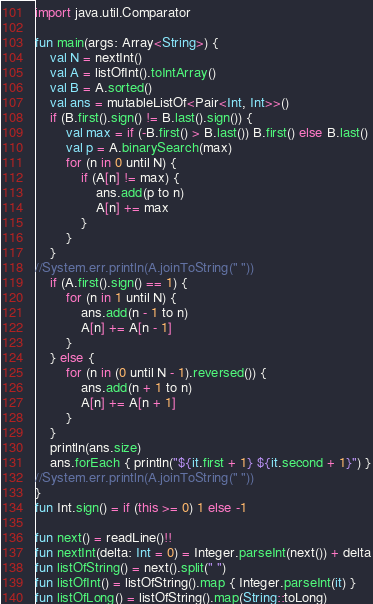<code> <loc_0><loc_0><loc_500><loc_500><_Kotlin_>import java.util.Comparator

fun main(args: Array<String>) {
    val N = nextInt()
    val A = listOfInt().toIntArray()
    val B = A.sorted()
    val ans = mutableListOf<Pair<Int, Int>>()
    if (B.first().sign() != B.last().sign()) {
        val max = if (-B.first() > B.last()) B.first() else B.last()
        val p = A.binarySearch(max)
        for (n in 0 until N) {
            if (A[n] != max) {
                ans.add(p to n)
                A[n] += max
            }
        }
    }
//System.err.println(A.joinToString(" "))
    if (A.first().sign() == 1) {
        for (n in 1 until N) {
            ans.add(n - 1 to n)
            A[n] += A[n - 1]
        }
    } else {
        for (n in (0 until N - 1).reversed()) {
            ans.add(n + 1 to n)
            A[n] += A[n + 1]
        }
    }
    println(ans.size)
    ans.forEach { println("${it.first + 1} ${it.second + 1}") }
//System.err.println(A.joinToString(" "))
}
fun Int.sign() = if (this >= 0) 1 else -1

fun next() = readLine()!!
fun nextInt(delta: Int = 0) = Integer.parseInt(next()) + delta
fun listOfString() = next().split(" ")
fun listOfInt() = listOfString().map { Integer.parseInt(it) }
fun listOfLong() = listOfString().map(String::toLong)
</code> 